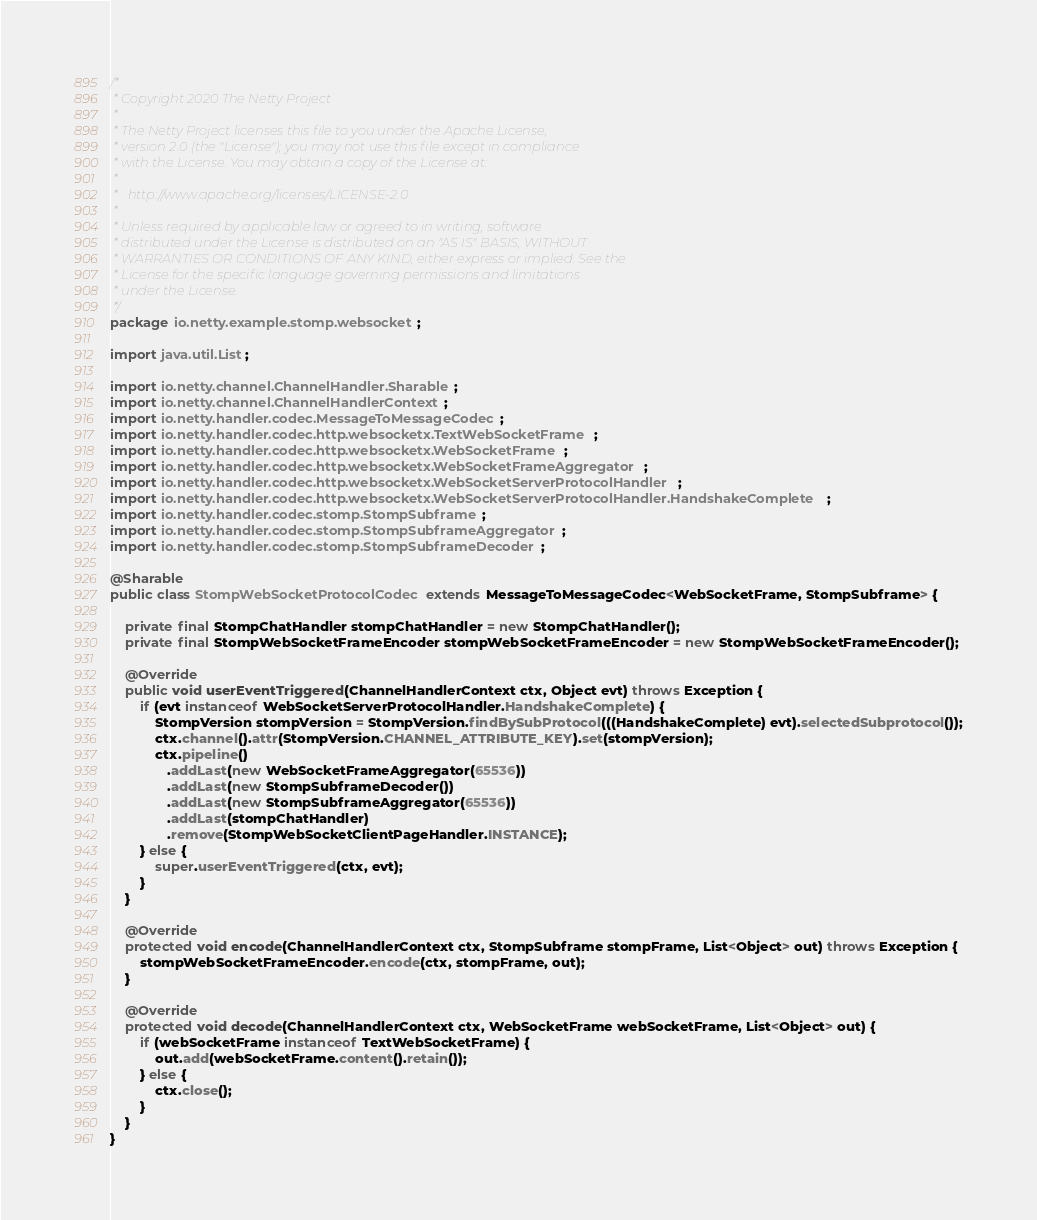<code> <loc_0><loc_0><loc_500><loc_500><_Java_>/*
 * Copyright 2020 The Netty Project
 *
 * The Netty Project licenses this file to you under the Apache License,
 * version 2.0 (the "License"); you may not use this file except in compliance
 * with the License. You may obtain a copy of the License at:
 *
 *   http://www.apache.org/licenses/LICENSE-2.0
 *
 * Unless required by applicable law or agreed to in writing, software
 * distributed under the License is distributed on an "AS IS" BASIS, WITHOUT
 * WARRANTIES OR CONDITIONS OF ANY KIND, either express or implied. See the
 * License for the specific language governing permissions and limitations
 * under the License.
 */
package io.netty.example.stomp.websocket;

import java.util.List;

import io.netty.channel.ChannelHandler.Sharable;
import io.netty.channel.ChannelHandlerContext;
import io.netty.handler.codec.MessageToMessageCodec;
import io.netty.handler.codec.http.websocketx.TextWebSocketFrame;
import io.netty.handler.codec.http.websocketx.WebSocketFrame;
import io.netty.handler.codec.http.websocketx.WebSocketFrameAggregator;
import io.netty.handler.codec.http.websocketx.WebSocketServerProtocolHandler;
import io.netty.handler.codec.http.websocketx.WebSocketServerProtocolHandler.HandshakeComplete;
import io.netty.handler.codec.stomp.StompSubframe;
import io.netty.handler.codec.stomp.StompSubframeAggregator;
import io.netty.handler.codec.stomp.StompSubframeDecoder;

@Sharable
public class StompWebSocketProtocolCodec extends MessageToMessageCodec<WebSocketFrame, StompSubframe> {

    private final StompChatHandler stompChatHandler = new StompChatHandler();
    private final StompWebSocketFrameEncoder stompWebSocketFrameEncoder = new StompWebSocketFrameEncoder();

    @Override
    public void userEventTriggered(ChannelHandlerContext ctx, Object evt) throws Exception {
        if (evt instanceof WebSocketServerProtocolHandler.HandshakeComplete) {
            StompVersion stompVersion = StompVersion.findBySubProtocol(((HandshakeComplete) evt).selectedSubprotocol());
            ctx.channel().attr(StompVersion.CHANNEL_ATTRIBUTE_KEY).set(stompVersion);
            ctx.pipeline()
               .addLast(new WebSocketFrameAggregator(65536))
               .addLast(new StompSubframeDecoder())
               .addLast(new StompSubframeAggregator(65536))
               .addLast(stompChatHandler)
               .remove(StompWebSocketClientPageHandler.INSTANCE);
        } else {
            super.userEventTriggered(ctx, evt);
        }
    }

    @Override
    protected void encode(ChannelHandlerContext ctx, StompSubframe stompFrame, List<Object> out) throws Exception {
        stompWebSocketFrameEncoder.encode(ctx, stompFrame, out);
    }

    @Override
    protected void decode(ChannelHandlerContext ctx, WebSocketFrame webSocketFrame, List<Object> out) {
        if (webSocketFrame instanceof TextWebSocketFrame) {
            out.add(webSocketFrame.content().retain());
        } else {
            ctx.close();
        }
    }
}
</code> 